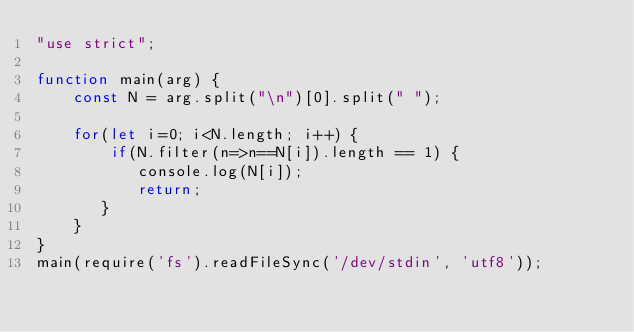Convert code to text. <code><loc_0><loc_0><loc_500><loc_500><_JavaScript_>"use strict";

function main(arg) {
    const N = arg.split("\n")[0].split(" ");
    
    for(let i=0; i<N.length; i++) {
        if(N.filter(n=>n==N[i]).length == 1) {
           console.log(N[i]);
           return;
       }
    }
}
main(require('fs').readFileSync('/dev/stdin', 'utf8'));</code> 